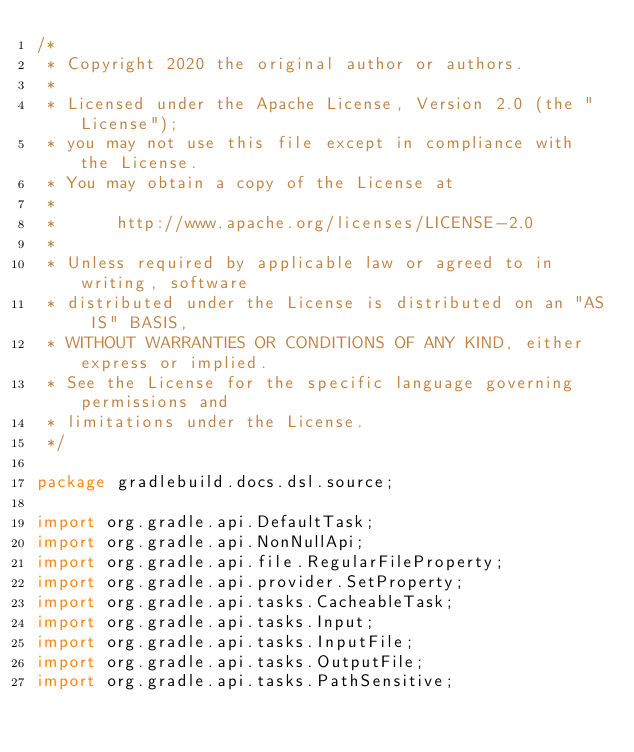Convert code to text. <code><loc_0><loc_0><loc_500><loc_500><_Java_>/*
 * Copyright 2020 the original author or authors.
 *
 * Licensed under the Apache License, Version 2.0 (the "License");
 * you may not use this file except in compliance with the License.
 * You may obtain a copy of the License at
 *
 *      http://www.apache.org/licenses/LICENSE-2.0
 *
 * Unless required by applicable law or agreed to in writing, software
 * distributed under the License is distributed on an "AS IS" BASIS,
 * WITHOUT WARRANTIES OR CONDITIONS OF ANY KIND, either express or implied.
 * See the License for the specific language governing permissions and
 * limitations under the License.
 */

package gradlebuild.docs.dsl.source;

import org.gradle.api.DefaultTask;
import org.gradle.api.NonNullApi;
import org.gradle.api.file.RegularFileProperty;
import org.gradle.api.provider.SetProperty;
import org.gradle.api.tasks.CacheableTask;
import org.gradle.api.tasks.Input;
import org.gradle.api.tasks.InputFile;
import org.gradle.api.tasks.OutputFile;
import org.gradle.api.tasks.PathSensitive;</code> 